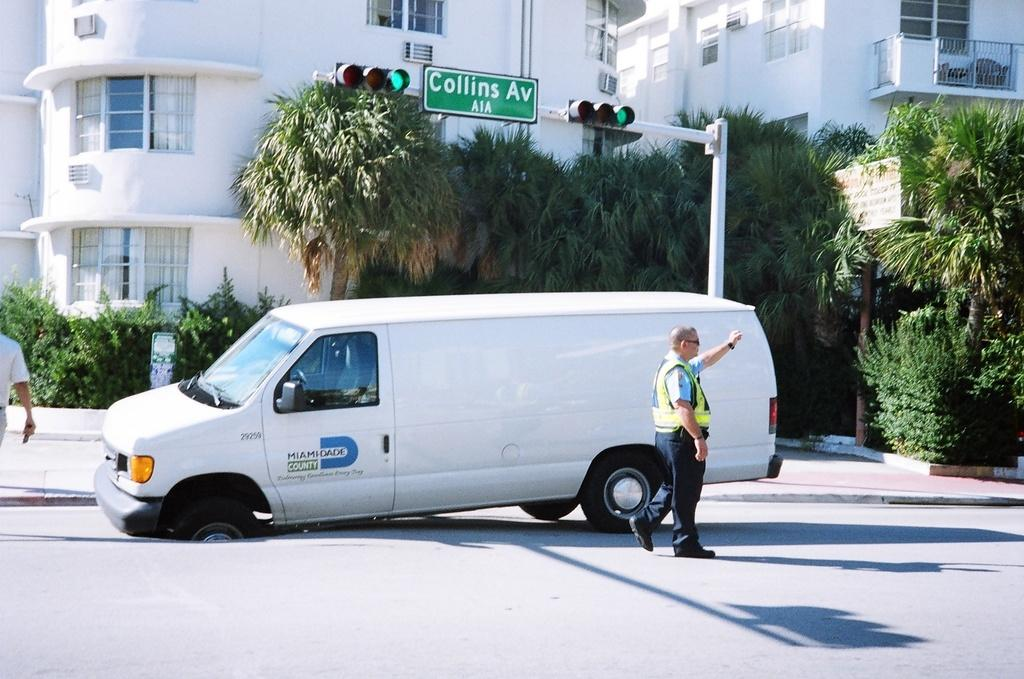<image>
Describe the image concisely. A white van with a flat tire and Miami Dade written on it. 